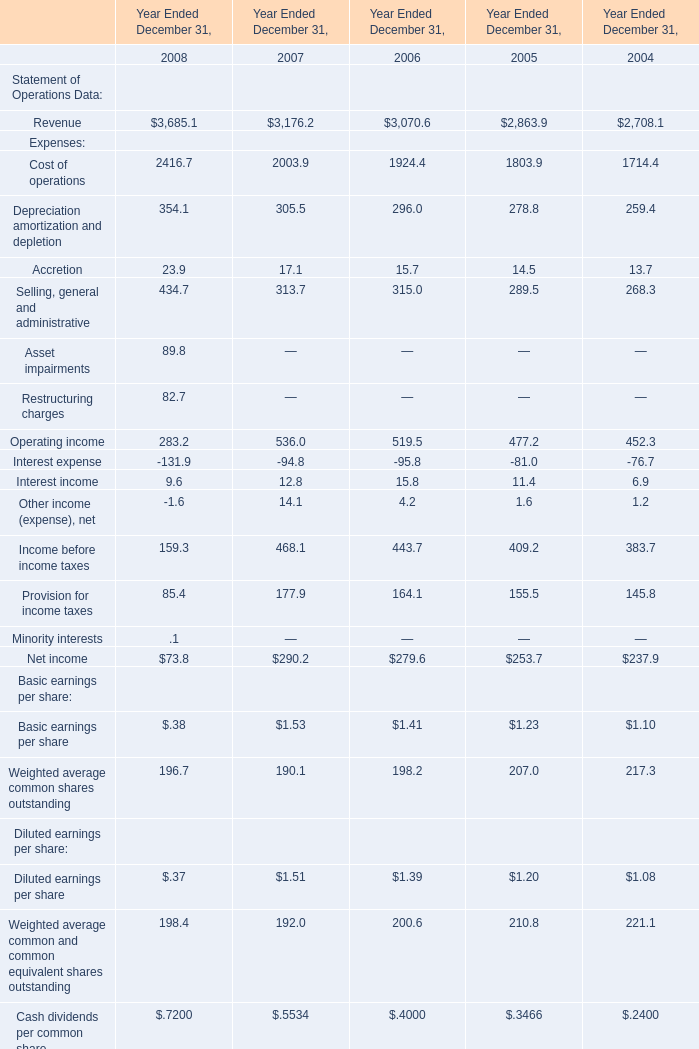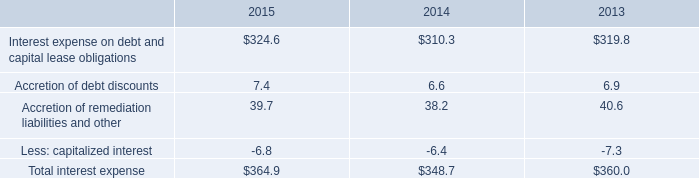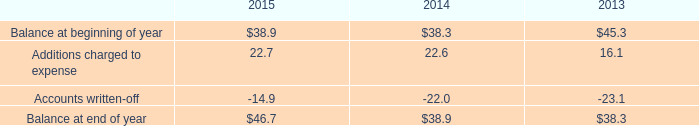In the year with the most Revenue, what is the growth rate of Accretion of Expenses for Year Ended December 31,? 
Computations: ((23.9 - 17.1) / 23.9)
Answer: 0.28452. 